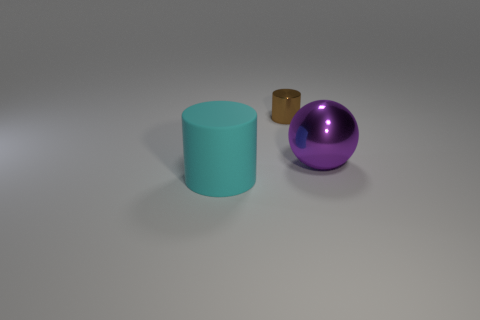Add 2 brown objects. How many objects exist? 5 Subtract all spheres. How many objects are left? 2 Add 2 shiny balls. How many shiny balls exist? 3 Subtract 1 cyan cylinders. How many objects are left? 2 Subtract all small brown cylinders. Subtract all brown things. How many objects are left? 1 Add 2 big purple shiny balls. How many big purple shiny balls are left? 3 